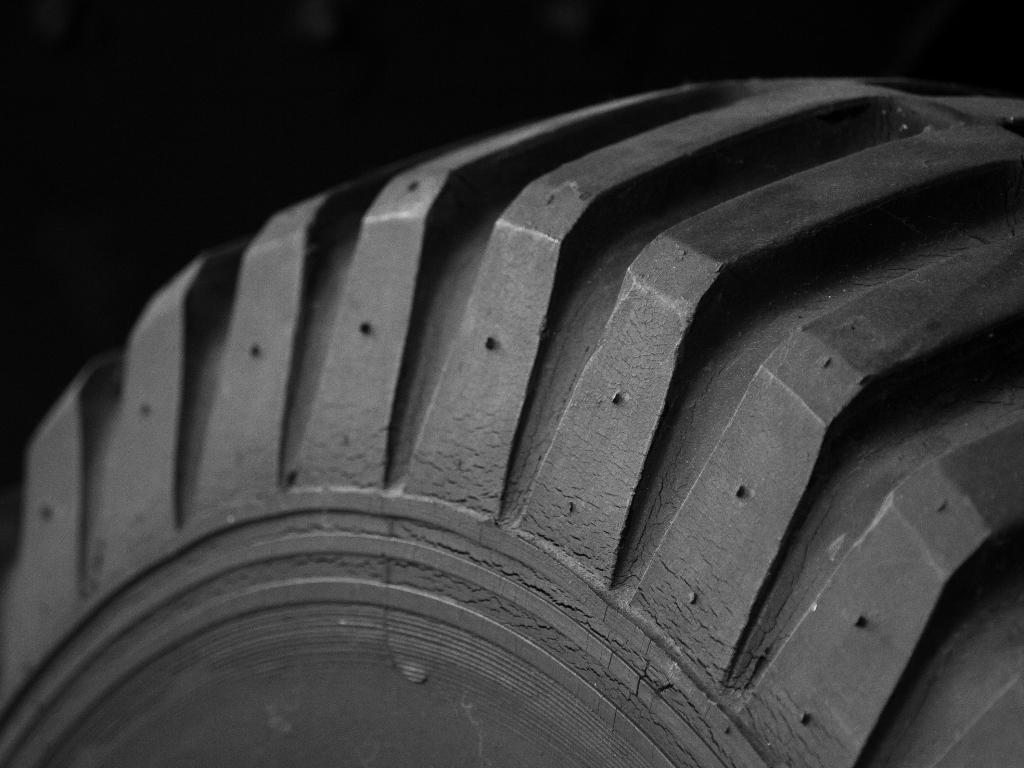What object is present in the image? The image contains a tire. What color is the background of the image? The background of the image is black. What message of peace can be seen on the tire in the image? There is no message of peace present on the tire in the image. 